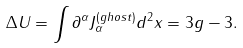<formula> <loc_0><loc_0><loc_500><loc_500>\Delta U = \int \partial ^ { \alpha } J _ { \alpha } ^ { ( g h o s t ) } d ^ { 2 } x = 3 g - 3 .</formula> 